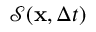<formula> <loc_0><loc_0><loc_500><loc_500>\mathcal { S } ( x , \Delta t )</formula> 